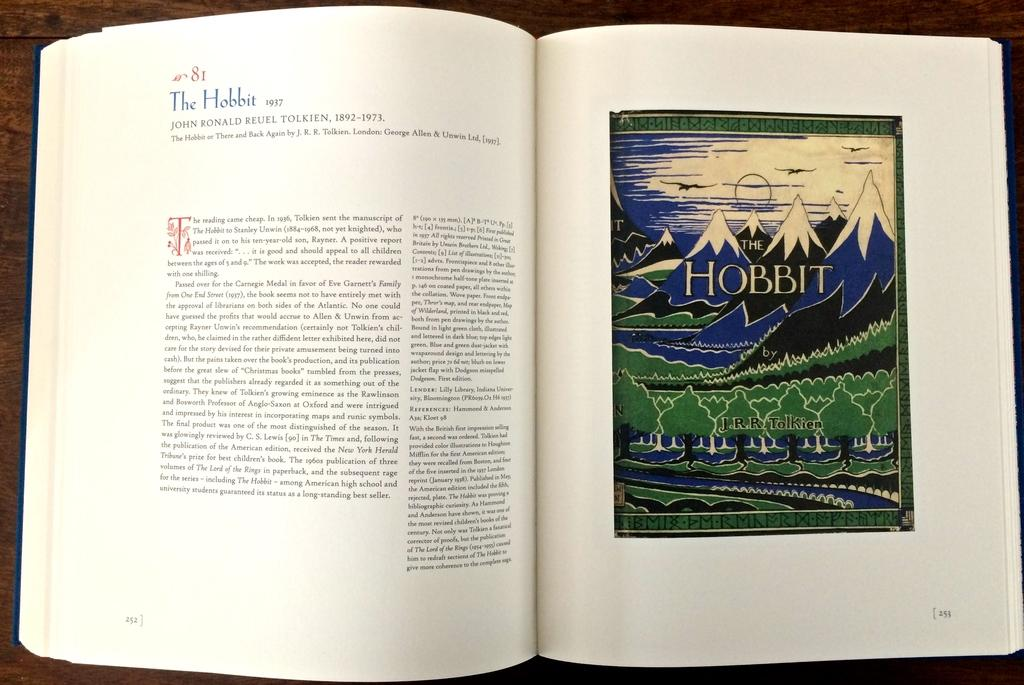Provide a one-sentence caption for the provided image. the book is open to a page with THE HOBBIT on the right page. 